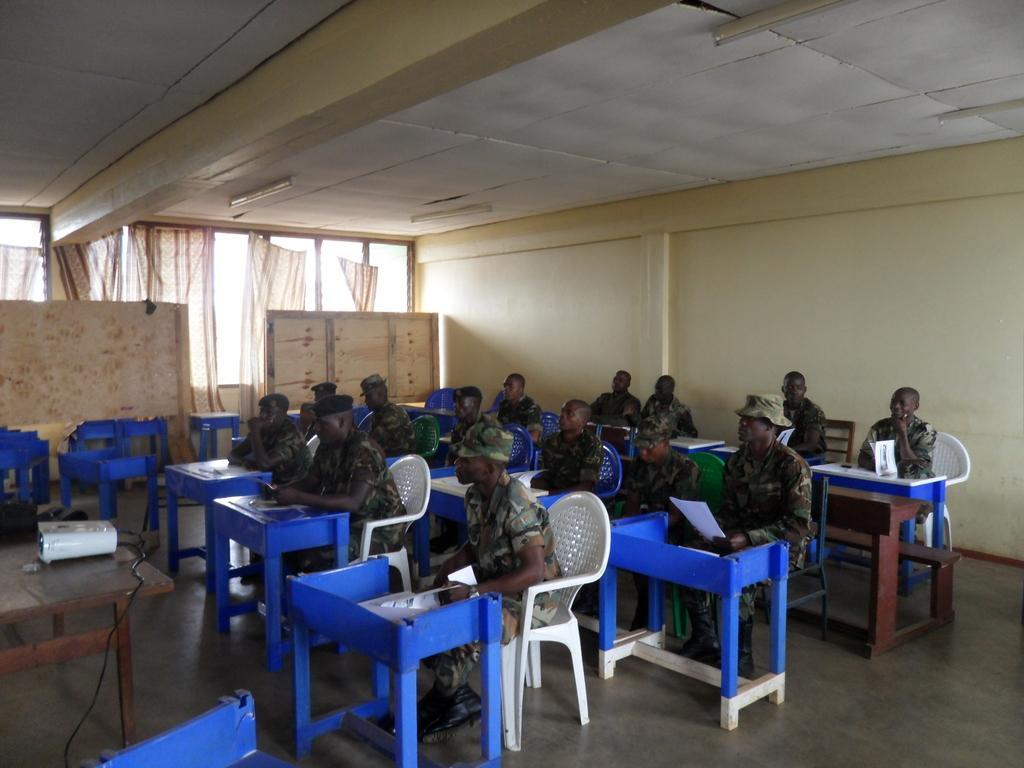Can you describe this image briefly? There are few people sitting on the chairs. These looks like a small table with some papers on it. This is a projector placed on the table. These are like a notice board. These are the windows with curtains hanging. This is the tube light attached to the rooftop. 